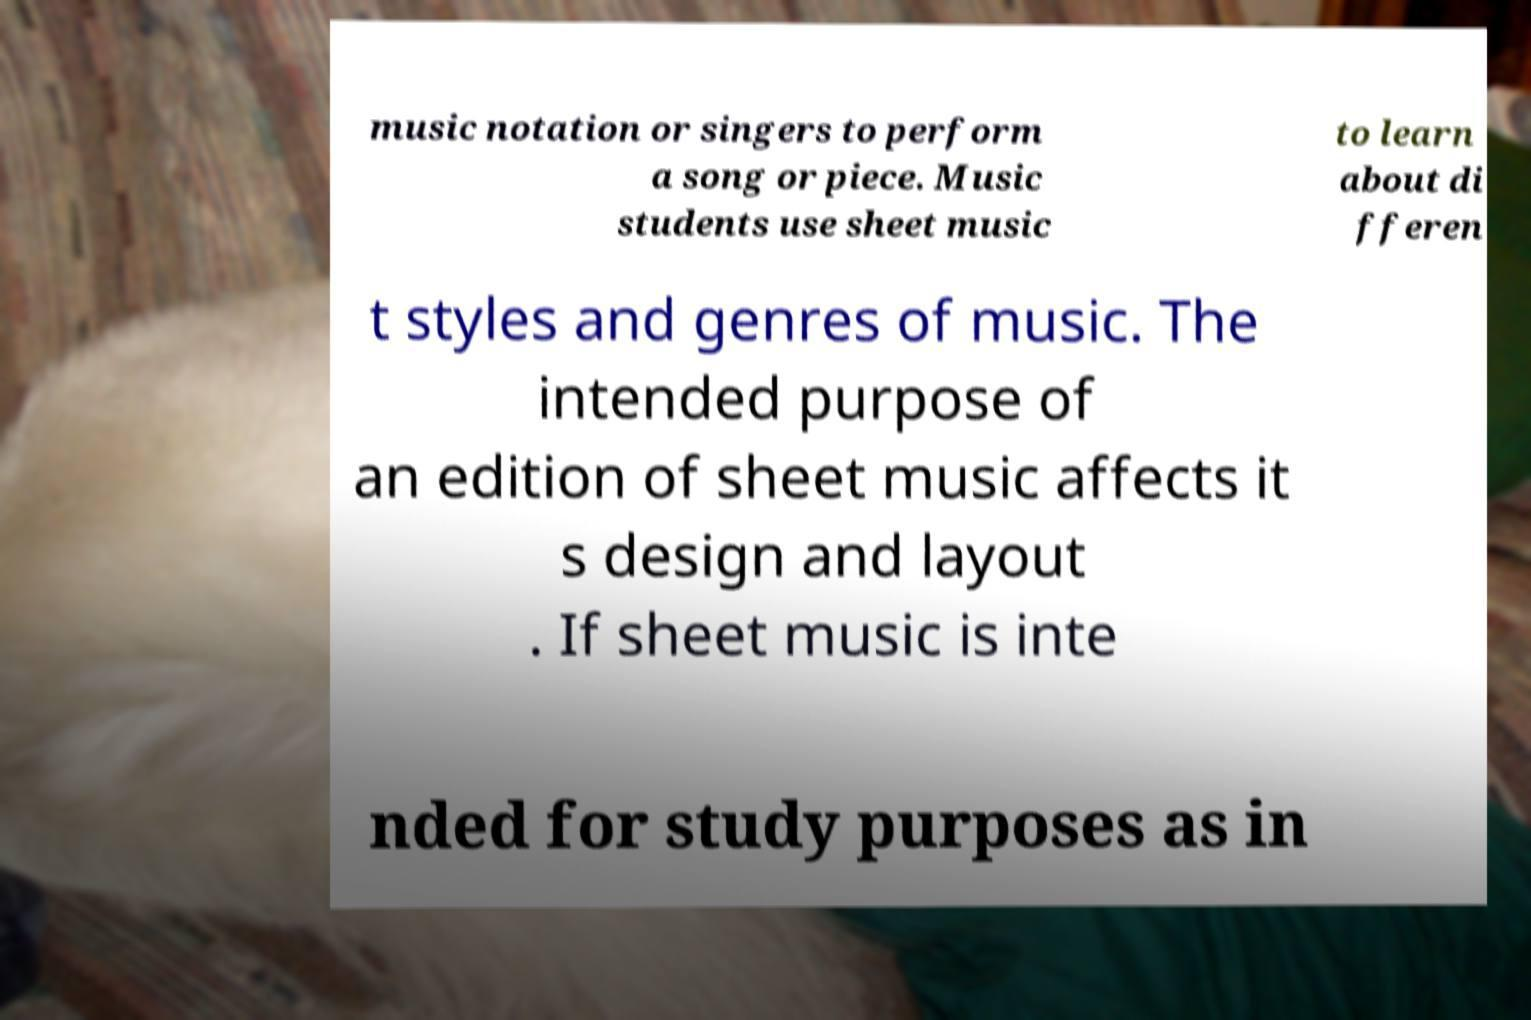What messages or text are displayed in this image? I need them in a readable, typed format. music notation or singers to perform a song or piece. Music students use sheet music to learn about di fferen t styles and genres of music. The intended purpose of an edition of sheet music affects it s design and layout . If sheet music is inte nded for study purposes as in 